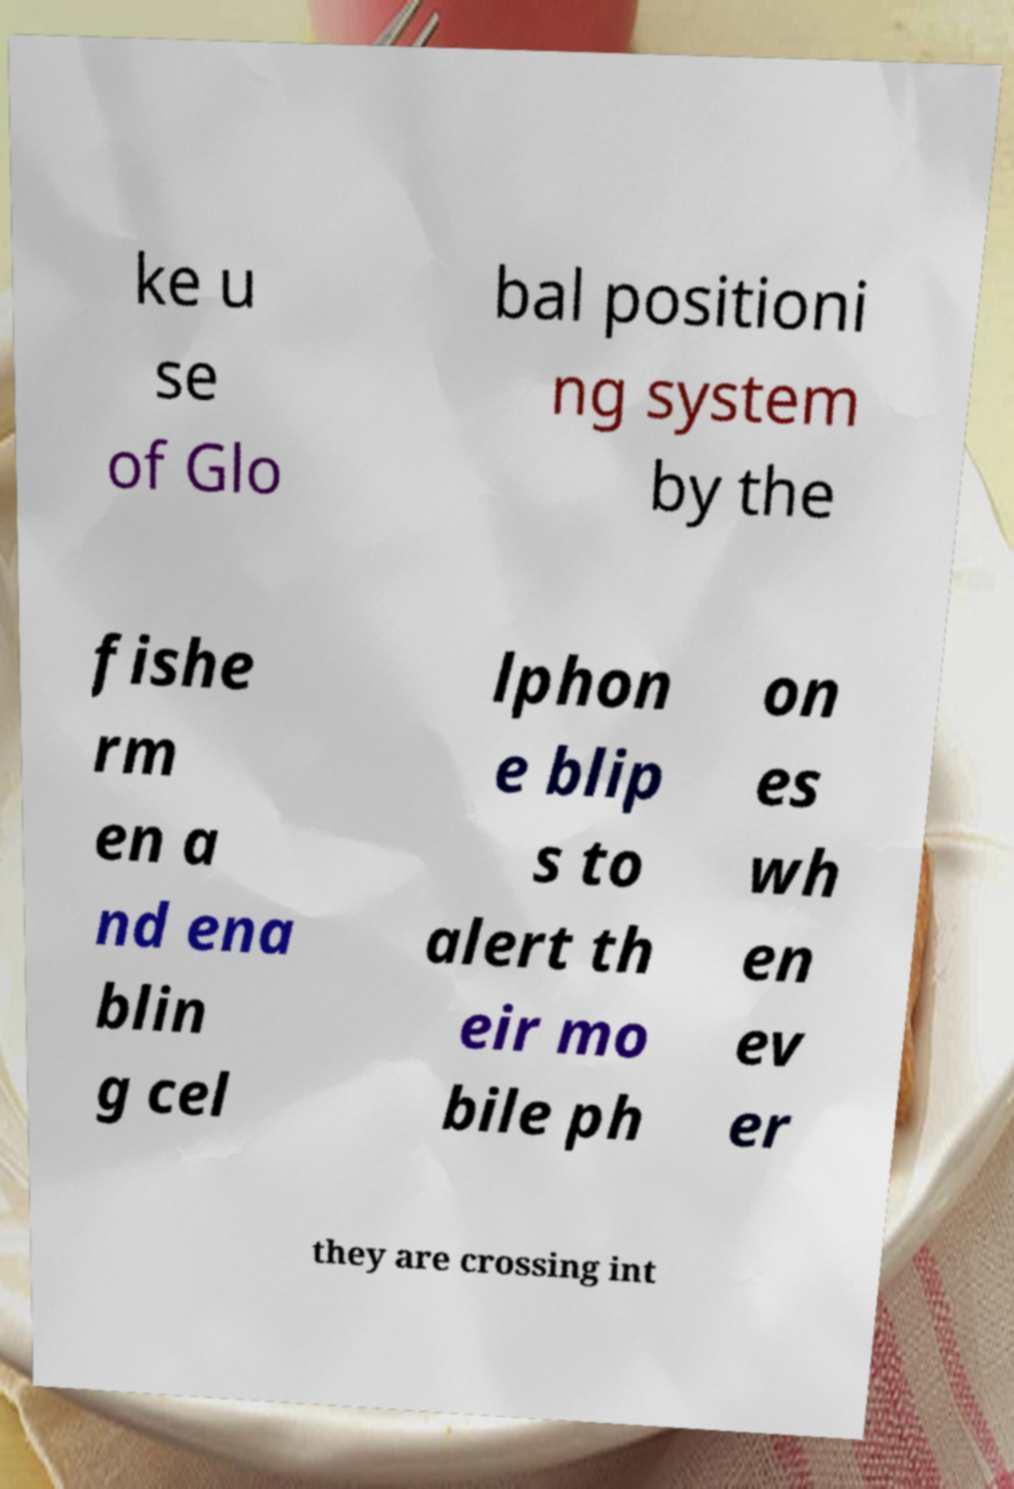Can you read and provide the text displayed in the image?This photo seems to have some interesting text. Can you extract and type it out for me? ke u se of Glo bal positioni ng system by the fishe rm en a nd ena blin g cel lphon e blip s to alert th eir mo bile ph on es wh en ev er they are crossing int 